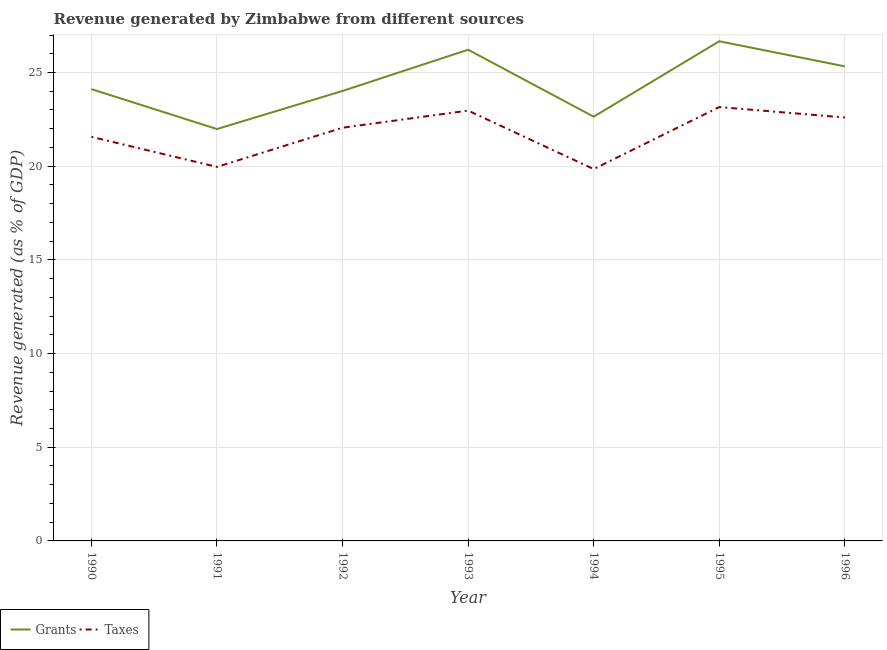How many different coloured lines are there?
Give a very brief answer. 2. Is the number of lines equal to the number of legend labels?
Offer a terse response. Yes. What is the revenue generated by taxes in 1994?
Your response must be concise. 19.85. Across all years, what is the maximum revenue generated by taxes?
Provide a succinct answer. 23.16. Across all years, what is the minimum revenue generated by grants?
Your response must be concise. 21.98. In which year was the revenue generated by taxes maximum?
Offer a very short reply. 1995. What is the total revenue generated by taxes in the graph?
Provide a succinct answer. 152.16. What is the difference between the revenue generated by grants in 1990 and that in 1996?
Your answer should be compact. -1.21. What is the difference between the revenue generated by taxes in 1993 and the revenue generated by grants in 1990?
Your response must be concise. -1.15. What is the average revenue generated by taxes per year?
Provide a short and direct response. 21.74. In the year 1991, what is the difference between the revenue generated by taxes and revenue generated by grants?
Ensure brevity in your answer.  -2.02. In how many years, is the revenue generated by taxes greater than 13 %?
Your response must be concise. 7. What is the ratio of the revenue generated by taxes in 1991 to that in 1992?
Make the answer very short. 0.91. Is the revenue generated by grants in 1990 less than that in 1992?
Offer a very short reply. No. What is the difference between the highest and the second highest revenue generated by taxes?
Your answer should be compact. 0.19. What is the difference between the highest and the lowest revenue generated by grants?
Your answer should be compact. 4.69. Is the sum of the revenue generated by taxes in 1990 and 1995 greater than the maximum revenue generated by grants across all years?
Your answer should be very brief. Yes. Are the values on the major ticks of Y-axis written in scientific E-notation?
Offer a terse response. No. Does the graph contain any zero values?
Your answer should be compact. No. Where does the legend appear in the graph?
Offer a terse response. Bottom left. How many legend labels are there?
Give a very brief answer. 2. How are the legend labels stacked?
Offer a very short reply. Horizontal. What is the title of the graph?
Your answer should be very brief. Revenue generated by Zimbabwe from different sources. What is the label or title of the Y-axis?
Your answer should be very brief. Revenue generated (as % of GDP). What is the Revenue generated (as % of GDP) of Grants in 1990?
Give a very brief answer. 24.11. What is the Revenue generated (as % of GDP) of Taxes in 1990?
Keep it short and to the point. 21.57. What is the Revenue generated (as % of GDP) of Grants in 1991?
Ensure brevity in your answer.  21.98. What is the Revenue generated (as % of GDP) in Taxes in 1991?
Make the answer very short. 19.96. What is the Revenue generated (as % of GDP) of Grants in 1992?
Your answer should be compact. 24.02. What is the Revenue generated (as % of GDP) in Taxes in 1992?
Provide a succinct answer. 22.05. What is the Revenue generated (as % of GDP) in Grants in 1993?
Offer a terse response. 26.22. What is the Revenue generated (as % of GDP) in Taxes in 1993?
Make the answer very short. 22.97. What is the Revenue generated (as % of GDP) of Grants in 1994?
Keep it short and to the point. 22.64. What is the Revenue generated (as % of GDP) of Taxes in 1994?
Offer a terse response. 19.85. What is the Revenue generated (as % of GDP) of Grants in 1995?
Your answer should be very brief. 26.67. What is the Revenue generated (as % of GDP) in Taxes in 1995?
Keep it short and to the point. 23.16. What is the Revenue generated (as % of GDP) in Grants in 1996?
Keep it short and to the point. 25.33. What is the Revenue generated (as % of GDP) of Taxes in 1996?
Provide a short and direct response. 22.6. Across all years, what is the maximum Revenue generated (as % of GDP) in Grants?
Offer a terse response. 26.67. Across all years, what is the maximum Revenue generated (as % of GDP) in Taxes?
Offer a terse response. 23.16. Across all years, what is the minimum Revenue generated (as % of GDP) in Grants?
Offer a terse response. 21.98. Across all years, what is the minimum Revenue generated (as % of GDP) in Taxes?
Keep it short and to the point. 19.85. What is the total Revenue generated (as % of GDP) of Grants in the graph?
Your answer should be very brief. 170.97. What is the total Revenue generated (as % of GDP) in Taxes in the graph?
Offer a very short reply. 152.16. What is the difference between the Revenue generated (as % of GDP) in Grants in 1990 and that in 1991?
Keep it short and to the point. 2.13. What is the difference between the Revenue generated (as % of GDP) of Taxes in 1990 and that in 1991?
Offer a very short reply. 1.6. What is the difference between the Revenue generated (as % of GDP) in Grants in 1990 and that in 1992?
Provide a short and direct response. 0.1. What is the difference between the Revenue generated (as % of GDP) of Taxes in 1990 and that in 1992?
Provide a short and direct response. -0.49. What is the difference between the Revenue generated (as % of GDP) of Grants in 1990 and that in 1993?
Your response must be concise. -2.1. What is the difference between the Revenue generated (as % of GDP) of Taxes in 1990 and that in 1993?
Provide a short and direct response. -1.4. What is the difference between the Revenue generated (as % of GDP) in Grants in 1990 and that in 1994?
Your answer should be very brief. 1.47. What is the difference between the Revenue generated (as % of GDP) of Taxes in 1990 and that in 1994?
Your response must be concise. 1.72. What is the difference between the Revenue generated (as % of GDP) of Grants in 1990 and that in 1995?
Provide a short and direct response. -2.55. What is the difference between the Revenue generated (as % of GDP) of Taxes in 1990 and that in 1995?
Your answer should be very brief. -1.59. What is the difference between the Revenue generated (as % of GDP) in Grants in 1990 and that in 1996?
Offer a terse response. -1.21. What is the difference between the Revenue generated (as % of GDP) in Taxes in 1990 and that in 1996?
Give a very brief answer. -1.03. What is the difference between the Revenue generated (as % of GDP) in Grants in 1991 and that in 1992?
Offer a terse response. -2.03. What is the difference between the Revenue generated (as % of GDP) of Taxes in 1991 and that in 1992?
Give a very brief answer. -2.09. What is the difference between the Revenue generated (as % of GDP) in Grants in 1991 and that in 1993?
Make the answer very short. -4.23. What is the difference between the Revenue generated (as % of GDP) of Taxes in 1991 and that in 1993?
Your answer should be compact. -3.01. What is the difference between the Revenue generated (as % of GDP) of Grants in 1991 and that in 1994?
Give a very brief answer. -0.66. What is the difference between the Revenue generated (as % of GDP) of Taxes in 1991 and that in 1994?
Your answer should be very brief. 0.12. What is the difference between the Revenue generated (as % of GDP) in Grants in 1991 and that in 1995?
Make the answer very short. -4.69. What is the difference between the Revenue generated (as % of GDP) of Taxes in 1991 and that in 1995?
Make the answer very short. -3.19. What is the difference between the Revenue generated (as % of GDP) of Grants in 1991 and that in 1996?
Provide a short and direct response. -3.35. What is the difference between the Revenue generated (as % of GDP) of Taxes in 1991 and that in 1996?
Your answer should be very brief. -2.64. What is the difference between the Revenue generated (as % of GDP) in Grants in 1992 and that in 1993?
Offer a terse response. -2.2. What is the difference between the Revenue generated (as % of GDP) in Taxes in 1992 and that in 1993?
Make the answer very short. -0.91. What is the difference between the Revenue generated (as % of GDP) in Grants in 1992 and that in 1994?
Make the answer very short. 1.37. What is the difference between the Revenue generated (as % of GDP) in Taxes in 1992 and that in 1994?
Keep it short and to the point. 2.21. What is the difference between the Revenue generated (as % of GDP) in Grants in 1992 and that in 1995?
Your answer should be compact. -2.65. What is the difference between the Revenue generated (as % of GDP) in Taxes in 1992 and that in 1995?
Provide a succinct answer. -1.1. What is the difference between the Revenue generated (as % of GDP) of Grants in 1992 and that in 1996?
Offer a very short reply. -1.31. What is the difference between the Revenue generated (as % of GDP) in Taxes in 1992 and that in 1996?
Give a very brief answer. -0.55. What is the difference between the Revenue generated (as % of GDP) in Grants in 1993 and that in 1994?
Offer a terse response. 3.58. What is the difference between the Revenue generated (as % of GDP) in Taxes in 1993 and that in 1994?
Offer a terse response. 3.12. What is the difference between the Revenue generated (as % of GDP) of Grants in 1993 and that in 1995?
Offer a very short reply. -0.45. What is the difference between the Revenue generated (as % of GDP) of Taxes in 1993 and that in 1995?
Offer a very short reply. -0.19. What is the difference between the Revenue generated (as % of GDP) of Grants in 1993 and that in 1996?
Your answer should be very brief. 0.89. What is the difference between the Revenue generated (as % of GDP) of Taxes in 1993 and that in 1996?
Your answer should be very brief. 0.37. What is the difference between the Revenue generated (as % of GDP) of Grants in 1994 and that in 1995?
Keep it short and to the point. -4.03. What is the difference between the Revenue generated (as % of GDP) in Taxes in 1994 and that in 1995?
Your answer should be compact. -3.31. What is the difference between the Revenue generated (as % of GDP) in Grants in 1994 and that in 1996?
Ensure brevity in your answer.  -2.69. What is the difference between the Revenue generated (as % of GDP) of Taxes in 1994 and that in 1996?
Ensure brevity in your answer.  -2.75. What is the difference between the Revenue generated (as % of GDP) in Grants in 1995 and that in 1996?
Provide a succinct answer. 1.34. What is the difference between the Revenue generated (as % of GDP) of Taxes in 1995 and that in 1996?
Your answer should be compact. 0.56. What is the difference between the Revenue generated (as % of GDP) of Grants in 1990 and the Revenue generated (as % of GDP) of Taxes in 1991?
Provide a succinct answer. 4.15. What is the difference between the Revenue generated (as % of GDP) of Grants in 1990 and the Revenue generated (as % of GDP) of Taxes in 1992?
Your answer should be very brief. 2.06. What is the difference between the Revenue generated (as % of GDP) in Grants in 1990 and the Revenue generated (as % of GDP) in Taxes in 1993?
Keep it short and to the point. 1.15. What is the difference between the Revenue generated (as % of GDP) of Grants in 1990 and the Revenue generated (as % of GDP) of Taxes in 1994?
Keep it short and to the point. 4.27. What is the difference between the Revenue generated (as % of GDP) of Grants in 1990 and the Revenue generated (as % of GDP) of Taxes in 1995?
Provide a short and direct response. 0.96. What is the difference between the Revenue generated (as % of GDP) in Grants in 1990 and the Revenue generated (as % of GDP) in Taxes in 1996?
Your response must be concise. 1.51. What is the difference between the Revenue generated (as % of GDP) in Grants in 1991 and the Revenue generated (as % of GDP) in Taxes in 1992?
Give a very brief answer. -0.07. What is the difference between the Revenue generated (as % of GDP) in Grants in 1991 and the Revenue generated (as % of GDP) in Taxes in 1993?
Make the answer very short. -0.99. What is the difference between the Revenue generated (as % of GDP) of Grants in 1991 and the Revenue generated (as % of GDP) of Taxes in 1994?
Your answer should be compact. 2.14. What is the difference between the Revenue generated (as % of GDP) of Grants in 1991 and the Revenue generated (as % of GDP) of Taxes in 1995?
Ensure brevity in your answer.  -1.17. What is the difference between the Revenue generated (as % of GDP) in Grants in 1991 and the Revenue generated (as % of GDP) in Taxes in 1996?
Provide a short and direct response. -0.62. What is the difference between the Revenue generated (as % of GDP) in Grants in 1992 and the Revenue generated (as % of GDP) in Taxes in 1993?
Give a very brief answer. 1.05. What is the difference between the Revenue generated (as % of GDP) of Grants in 1992 and the Revenue generated (as % of GDP) of Taxes in 1994?
Give a very brief answer. 4.17. What is the difference between the Revenue generated (as % of GDP) in Grants in 1992 and the Revenue generated (as % of GDP) in Taxes in 1995?
Give a very brief answer. 0.86. What is the difference between the Revenue generated (as % of GDP) of Grants in 1992 and the Revenue generated (as % of GDP) of Taxes in 1996?
Your answer should be very brief. 1.42. What is the difference between the Revenue generated (as % of GDP) of Grants in 1993 and the Revenue generated (as % of GDP) of Taxes in 1994?
Your answer should be compact. 6.37. What is the difference between the Revenue generated (as % of GDP) in Grants in 1993 and the Revenue generated (as % of GDP) in Taxes in 1995?
Your answer should be compact. 3.06. What is the difference between the Revenue generated (as % of GDP) of Grants in 1993 and the Revenue generated (as % of GDP) of Taxes in 1996?
Ensure brevity in your answer.  3.62. What is the difference between the Revenue generated (as % of GDP) in Grants in 1994 and the Revenue generated (as % of GDP) in Taxes in 1995?
Ensure brevity in your answer.  -0.52. What is the difference between the Revenue generated (as % of GDP) in Grants in 1994 and the Revenue generated (as % of GDP) in Taxes in 1996?
Your answer should be very brief. 0.04. What is the difference between the Revenue generated (as % of GDP) in Grants in 1995 and the Revenue generated (as % of GDP) in Taxes in 1996?
Offer a terse response. 4.07. What is the average Revenue generated (as % of GDP) of Grants per year?
Keep it short and to the point. 24.42. What is the average Revenue generated (as % of GDP) of Taxes per year?
Offer a terse response. 21.74. In the year 1990, what is the difference between the Revenue generated (as % of GDP) in Grants and Revenue generated (as % of GDP) in Taxes?
Offer a very short reply. 2.55. In the year 1991, what is the difference between the Revenue generated (as % of GDP) of Grants and Revenue generated (as % of GDP) of Taxes?
Your answer should be very brief. 2.02. In the year 1992, what is the difference between the Revenue generated (as % of GDP) in Grants and Revenue generated (as % of GDP) in Taxes?
Provide a succinct answer. 1.96. In the year 1993, what is the difference between the Revenue generated (as % of GDP) in Grants and Revenue generated (as % of GDP) in Taxes?
Your answer should be very brief. 3.25. In the year 1994, what is the difference between the Revenue generated (as % of GDP) of Grants and Revenue generated (as % of GDP) of Taxes?
Provide a short and direct response. 2.79. In the year 1995, what is the difference between the Revenue generated (as % of GDP) in Grants and Revenue generated (as % of GDP) in Taxes?
Give a very brief answer. 3.51. In the year 1996, what is the difference between the Revenue generated (as % of GDP) of Grants and Revenue generated (as % of GDP) of Taxes?
Your answer should be very brief. 2.73. What is the ratio of the Revenue generated (as % of GDP) of Grants in 1990 to that in 1991?
Your answer should be very brief. 1.1. What is the ratio of the Revenue generated (as % of GDP) in Taxes in 1990 to that in 1991?
Provide a short and direct response. 1.08. What is the ratio of the Revenue generated (as % of GDP) of Grants in 1990 to that in 1992?
Provide a short and direct response. 1. What is the ratio of the Revenue generated (as % of GDP) in Taxes in 1990 to that in 1992?
Offer a terse response. 0.98. What is the ratio of the Revenue generated (as % of GDP) of Grants in 1990 to that in 1993?
Your answer should be very brief. 0.92. What is the ratio of the Revenue generated (as % of GDP) of Taxes in 1990 to that in 1993?
Keep it short and to the point. 0.94. What is the ratio of the Revenue generated (as % of GDP) in Grants in 1990 to that in 1994?
Ensure brevity in your answer.  1.06. What is the ratio of the Revenue generated (as % of GDP) in Taxes in 1990 to that in 1994?
Ensure brevity in your answer.  1.09. What is the ratio of the Revenue generated (as % of GDP) in Grants in 1990 to that in 1995?
Ensure brevity in your answer.  0.9. What is the ratio of the Revenue generated (as % of GDP) in Taxes in 1990 to that in 1995?
Your answer should be compact. 0.93. What is the ratio of the Revenue generated (as % of GDP) in Grants in 1990 to that in 1996?
Make the answer very short. 0.95. What is the ratio of the Revenue generated (as % of GDP) of Taxes in 1990 to that in 1996?
Keep it short and to the point. 0.95. What is the ratio of the Revenue generated (as % of GDP) in Grants in 1991 to that in 1992?
Keep it short and to the point. 0.92. What is the ratio of the Revenue generated (as % of GDP) of Taxes in 1991 to that in 1992?
Make the answer very short. 0.91. What is the ratio of the Revenue generated (as % of GDP) of Grants in 1991 to that in 1993?
Make the answer very short. 0.84. What is the ratio of the Revenue generated (as % of GDP) in Taxes in 1991 to that in 1993?
Ensure brevity in your answer.  0.87. What is the ratio of the Revenue generated (as % of GDP) of Grants in 1991 to that in 1994?
Offer a terse response. 0.97. What is the ratio of the Revenue generated (as % of GDP) of Grants in 1991 to that in 1995?
Your response must be concise. 0.82. What is the ratio of the Revenue generated (as % of GDP) in Taxes in 1991 to that in 1995?
Offer a very short reply. 0.86. What is the ratio of the Revenue generated (as % of GDP) of Grants in 1991 to that in 1996?
Ensure brevity in your answer.  0.87. What is the ratio of the Revenue generated (as % of GDP) in Taxes in 1991 to that in 1996?
Your response must be concise. 0.88. What is the ratio of the Revenue generated (as % of GDP) of Grants in 1992 to that in 1993?
Your response must be concise. 0.92. What is the ratio of the Revenue generated (as % of GDP) in Taxes in 1992 to that in 1993?
Give a very brief answer. 0.96. What is the ratio of the Revenue generated (as % of GDP) of Grants in 1992 to that in 1994?
Ensure brevity in your answer.  1.06. What is the ratio of the Revenue generated (as % of GDP) of Taxes in 1992 to that in 1994?
Offer a very short reply. 1.11. What is the ratio of the Revenue generated (as % of GDP) of Grants in 1992 to that in 1995?
Your response must be concise. 0.9. What is the ratio of the Revenue generated (as % of GDP) in Taxes in 1992 to that in 1995?
Keep it short and to the point. 0.95. What is the ratio of the Revenue generated (as % of GDP) in Grants in 1992 to that in 1996?
Your answer should be compact. 0.95. What is the ratio of the Revenue generated (as % of GDP) in Taxes in 1992 to that in 1996?
Give a very brief answer. 0.98. What is the ratio of the Revenue generated (as % of GDP) in Grants in 1993 to that in 1994?
Keep it short and to the point. 1.16. What is the ratio of the Revenue generated (as % of GDP) in Taxes in 1993 to that in 1994?
Give a very brief answer. 1.16. What is the ratio of the Revenue generated (as % of GDP) in Grants in 1993 to that in 1995?
Ensure brevity in your answer.  0.98. What is the ratio of the Revenue generated (as % of GDP) in Grants in 1993 to that in 1996?
Keep it short and to the point. 1.04. What is the ratio of the Revenue generated (as % of GDP) of Taxes in 1993 to that in 1996?
Your answer should be very brief. 1.02. What is the ratio of the Revenue generated (as % of GDP) of Grants in 1994 to that in 1995?
Your answer should be very brief. 0.85. What is the ratio of the Revenue generated (as % of GDP) in Grants in 1994 to that in 1996?
Your answer should be very brief. 0.89. What is the ratio of the Revenue generated (as % of GDP) in Taxes in 1994 to that in 1996?
Provide a short and direct response. 0.88. What is the ratio of the Revenue generated (as % of GDP) of Grants in 1995 to that in 1996?
Ensure brevity in your answer.  1.05. What is the ratio of the Revenue generated (as % of GDP) of Taxes in 1995 to that in 1996?
Offer a terse response. 1.02. What is the difference between the highest and the second highest Revenue generated (as % of GDP) in Grants?
Provide a short and direct response. 0.45. What is the difference between the highest and the second highest Revenue generated (as % of GDP) of Taxes?
Provide a short and direct response. 0.19. What is the difference between the highest and the lowest Revenue generated (as % of GDP) in Grants?
Offer a terse response. 4.69. What is the difference between the highest and the lowest Revenue generated (as % of GDP) in Taxes?
Give a very brief answer. 3.31. 